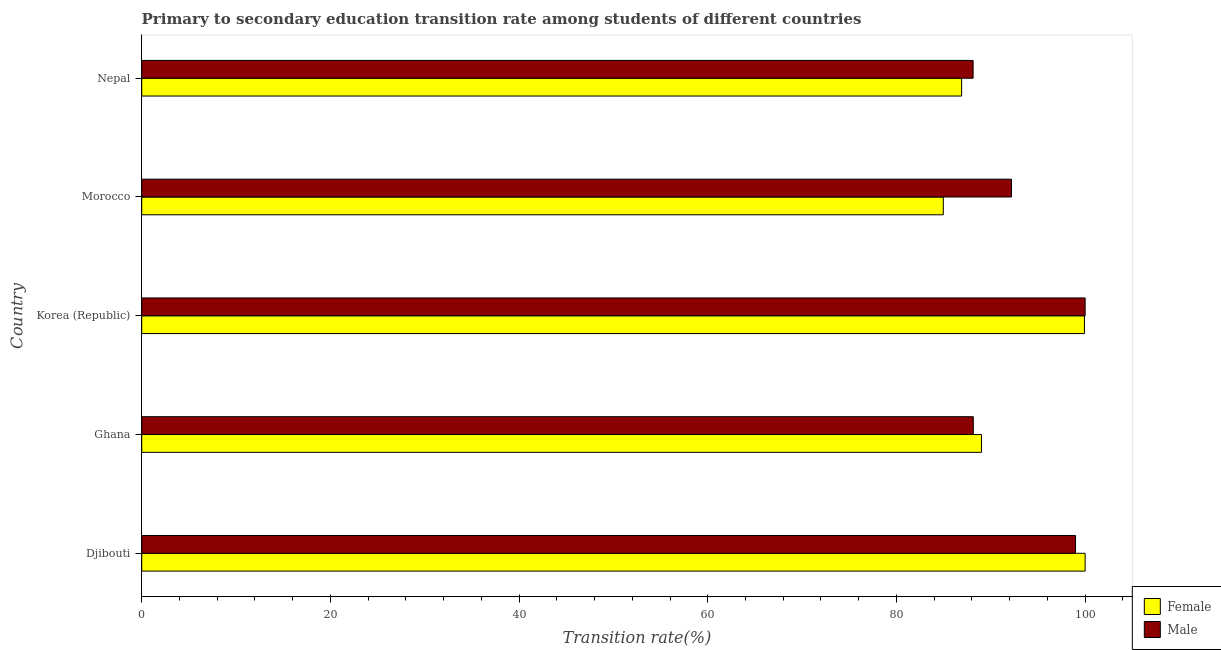How many different coloured bars are there?
Provide a succinct answer. 2. How many groups of bars are there?
Your response must be concise. 5. Are the number of bars on each tick of the Y-axis equal?
Offer a very short reply. Yes. How many bars are there on the 2nd tick from the top?
Offer a terse response. 2. How many bars are there on the 2nd tick from the bottom?
Your answer should be compact. 2. What is the label of the 1st group of bars from the top?
Provide a short and direct response. Nepal. What is the transition rate among male students in Korea (Republic)?
Give a very brief answer. 100. Across all countries, what is the maximum transition rate among male students?
Offer a very short reply. 100. Across all countries, what is the minimum transition rate among male students?
Provide a short and direct response. 88.13. In which country was the transition rate among female students minimum?
Your answer should be compact. Morocco. What is the total transition rate among male students in the graph?
Your answer should be very brief. 467.45. What is the difference between the transition rate among female students in Djibouti and that in Nepal?
Provide a short and direct response. 13.09. What is the difference between the transition rate among female students in Korea (Republic) and the transition rate among male students in Nepal?
Provide a short and direct response. 11.8. What is the average transition rate among female students per country?
Offer a terse response. 92.16. What is the difference between the transition rate among male students and transition rate among female students in Morocco?
Keep it short and to the point. 7.23. What is the ratio of the transition rate among female students in Djibouti to that in Nepal?
Make the answer very short. 1.15. Is the difference between the transition rate among male students in Ghana and Morocco greater than the difference between the transition rate among female students in Ghana and Morocco?
Your answer should be compact. No. What is the difference between the highest and the lowest transition rate among female students?
Your answer should be very brief. 15.03. In how many countries, is the transition rate among male students greater than the average transition rate among male students taken over all countries?
Offer a very short reply. 2. Is the sum of the transition rate among female students in Ghana and Morocco greater than the maximum transition rate among male students across all countries?
Provide a short and direct response. Yes. What is the difference between two consecutive major ticks on the X-axis?
Provide a succinct answer. 20. Where does the legend appear in the graph?
Offer a terse response. Bottom right. How are the legend labels stacked?
Ensure brevity in your answer.  Vertical. What is the title of the graph?
Your answer should be very brief. Primary to secondary education transition rate among students of different countries. What is the label or title of the X-axis?
Your response must be concise. Transition rate(%). What is the label or title of the Y-axis?
Offer a terse response. Country. What is the Transition rate(%) in Male in Djibouti?
Provide a short and direct response. 98.98. What is the Transition rate(%) of Female in Ghana?
Offer a very short reply. 89.01. What is the Transition rate(%) of Male in Ghana?
Give a very brief answer. 88.14. What is the Transition rate(%) in Female in Korea (Republic)?
Make the answer very short. 99.92. What is the Transition rate(%) in Male in Korea (Republic)?
Your answer should be compact. 100. What is the Transition rate(%) of Female in Morocco?
Make the answer very short. 84.97. What is the Transition rate(%) in Male in Morocco?
Provide a succinct answer. 92.19. What is the Transition rate(%) of Female in Nepal?
Keep it short and to the point. 86.91. What is the Transition rate(%) of Male in Nepal?
Make the answer very short. 88.13. Across all countries, what is the minimum Transition rate(%) of Female?
Ensure brevity in your answer.  84.97. Across all countries, what is the minimum Transition rate(%) of Male?
Your response must be concise. 88.13. What is the total Transition rate(%) of Female in the graph?
Make the answer very short. 460.81. What is the total Transition rate(%) of Male in the graph?
Make the answer very short. 467.45. What is the difference between the Transition rate(%) of Female in Djibouti and that in Ghana?
Provide a short and direct response. 10.99. What is the difference between the Transition rate(%) in Male in Djibouti and that in Ghana?
Offer a terse response. 10.84. What is the difference between the Transition rate(%) in Female in Djibouti and that in Korea (Republic)?
Keep it short and to the point. 0.08. What is the difference between the Transition rate(%) of Male in Djibouti and that in Korea (Republic)?
Ensure brevity in your answer.  -1.02. What is the difference between the Transition rate(%) in Female in Djibouti and that in Morocco?
Your answer should be very brief. 15.03. What is the difference between the Transition rate(%) of Male in Djibouti and that in Morocco?
Give a very brief answer. 6.79. What is the difference between the Transition rate(%) in Female in Djibouti and that in Nepal?
Ensure brevity in your answer.  13.09. What is the difference between the Transition rate(%) in Male in Djibouti and that in Nepal?
Keep it short and to the point. 10.86. What is the difference between the Transition rate(%) of Female in Ghana and that in Korea (Republic)?
Keep it short and to the point. -10.91. What is the difference between the Transition rate(%) of Male in Ghana and that in Korea (Republic)?
Offer a very short reply. -11.86. What is the difference between the Transition rate(%) in Female in Ghana and that in Morocco?
Ensure brevity in your answer.  4.05. What is the difference between the Transition rate(%) in Male in Ghana and that in Morocco?
Your response must be concise. -4.05. What is the difference between the Transition rate(%) of Female in Ghana and that in Nepal?
Offer a terse response. 2.1. What is the difference between the Transition rate(%) of Male in Ghana and that in Nepal?
Offer a very short reply. 0.02. What is the difference between the Transition rate(%) in Female in Korea (Republic) and that in Morocco?
Your answer should be very brief. 14.96. What is the difference between the Transition rate(%) in Male in Korea (Republic) and that in Morocco?
Keep it short and to the point. 7.81. What is the difference between the Transition rate(%) of Female in Korea (Republic) and that in Nepal?
Make the answer very short. 13.02. What is the difference between the Transition rate(%) in Male in Korea (Republic) and that in Nepal?
Provide a short and direct response. 11.87. What is the difference between the Transition rate(%) of Female in Morocco and that in Nepal?
Make the answer very short. -1.94. What is the difference between the Transition rate(%) in Male in Morocco and that in Nepal?
Your answer should be compact. 4.07. What is the difference between the Transition rate(%) of Female in Djibouti and the Transition rate(%) of Male in Ghana?
Offer a terse response. 11.86. What is the difference between the Transition rate(%) in Female in Djibouti and the Transition rate(%) in Male in Korea (Republic)?
Give a very brief answer. 0. What is the difference between the Transition rate(%) of Female in Djibouti and the Transition rate(%) of Male in Morocco?
Provide a succinct answer. 7.81. What is the difference between the Transition rate(%) of Female in Djibouti and the Transition rate(%) of Male in Nepal?
Make the answer very short. 11.87. What is the difference between the Transition rate(%) of Female in Ghana and the Transition rate(%) of Male in Korea (Republic)?
Your response must be concise. -10.99. What is the difference between the Transition rate(%) of Female in Ghana and the Transition rate(%) of Male in Morocco?
Offer a terse response. -3.18. What is the difference between the Transition rate(%) in Female in Ghana and the Transition rate(%) in Male in Nepal?
Your answer should be very brief. 0.88. What is the difference between the Transition rate(%) of Female in Korea (Republic) and the Transition rate(%) of Male in Morocco?
Keep it short and to the point. 7.73. What is the difference between the Transition rate(%) in Female in Korea (Republic) and the Transition rate(%) in Male in Nepal?
Ensure brevity in your answer.  11.8. What is the difference between the Transition rate(%) of Female in Morocco and the Transition rate(%) of Male in Nepal?
Keep it short and to the point. -3.16. What is the average Transition rate(%) in Female per country?
Your answer should be compact. 92.16. What is the average Transition rate(%) of Male per country?
Ensure brevity in your answer.  93.49. What is the difference between the Transition rate(%) in Female and Transition rate(%) in Male in Djibouti?
Make the answer very short. 1.02. What is the difference between the Transition rate(%) in Female and Transition rate(%) in Male in Ghana?
Your answer should be compact. 0.87. What is the difference between the Transition rate(%) of Female and Transition rate(%) of Male in Korea (Republic)?
Ensure brevity in your answer.  -0.08. What is the difference between the Transition rate(%) of Female and Transition rate(%) of Male in Morocco?
Offer a very short reply. -7.23. What is the difference between the Transition rate(%) of Female and Transition rate(%) of Male in Nepal?
Offer a terse response. -1.22. What is the ratio of the Transition rate(%) of Female in Djibouti to that in Ghana?
Offer a very short reply. 1.12. What is the ratio of the Transition rate(%) in Male in Djibouti to that in Ghana?
Your response must be concise. 1.12. What is the ratio of the Transition rate(%) in Female in Djibouti to that in Korea (Republic)?
Make the answer very short. 1. What is the ratio of the Transition rate(%) of Female in Djibouti to that in Morocco?
Your answer should be very brief. 1.18. What is the ratio of the Transition rate(%) of Male in Djibouti to that in Morocco?
Your response must be concise. 1.07. What is the ratio of the Transition rate(%) of Female in Djibouti to that in Nepal?
Offer a terse response. 1.15. What is the ratio of the Transition rate(%) in Male in Djibouti to that in Nepal?
Keep it short and to the point. 1.12. What is the ratio of the Transition rate(%) of Female in Ghana to that in Korea (Republic)?
Offer a terse response. 0.89. What is the ratio of the Transition rate(%) in Male in Ghana to that in Korea (Republic)?
Offer a terse response. 0.88. What is the ratio of the Transition rate(%) of Female in Ghana to that in Morocco?
Give a very brief answer. 1.05. What is the ratio of the Transition rate(%) of Male in Ghana to that in Morocco?
Give a very brief answer. 0.96. What is the ratio of the Transition rate(%) of Female in Ghana to that in Nepal?
Keep it short and to the point. 1.02. What is the ratio of the Transition rate(%) in Female in Korea (Republic) to that in Morocco?
Your response must be concise. 1.18. What is the ratio of the Transition rate(%) in Male in Korea (Republic) to that in Morocco?
Your response must be concise. 1.08. What is the ratio of the Transition rate(%) in Female in Korea (Republic) to that in Nepal?
Keep it short and to the point. 1.15. What is the ratio of the Transition rate(%) in Male in Korea (Republic) to that in Nepal?
Offer a very short reply. 1.13. What is the ratio of the Transition rate(%) in Female in Morocco to that in Nepal?
Your response must be concise. 0.98. What is the ratio of the Transition rate(%) of Male in Morocco to that in Nepal?
Make the answer very short. 1.05. What is the difference between the highest and the second highest Transition rate(%) of Female?
Keep it short and to the point. 0.08. What is the difference between the highest and the second highest Transition rate(%) in Male?
Your response must be concise. 1.02. What is the difference between the highest and the lowest Transition rate(%) of Female?
Your response must be concise. 15.03. What is the difference between the highest and the lowest Transition rate(%) of Male?
Your answer should be compact. 11.87. 